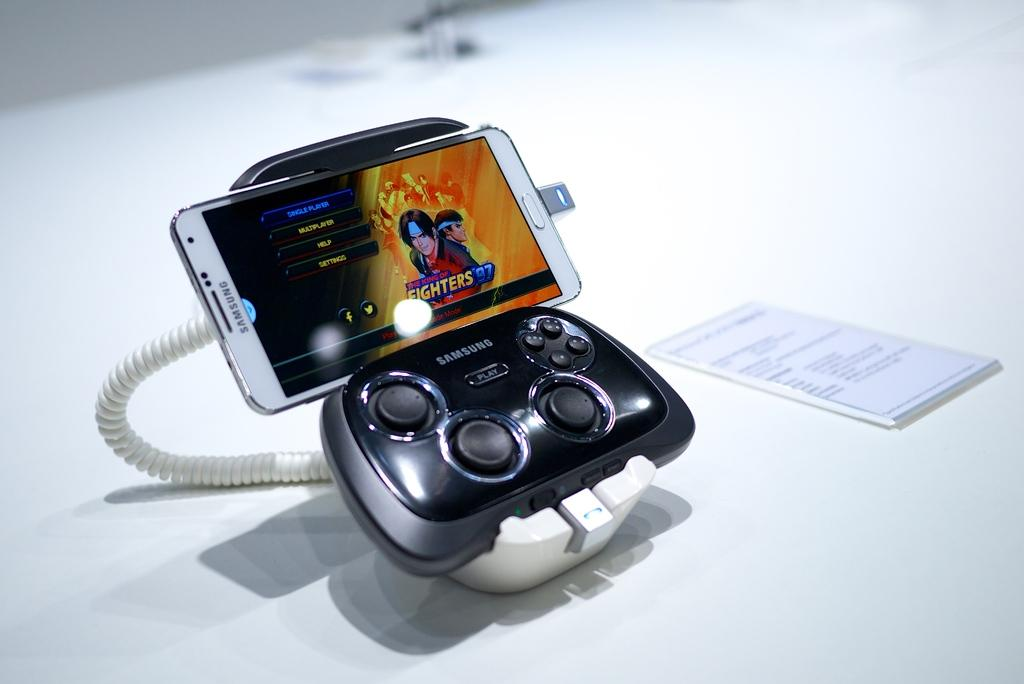Provide a one-sentence caption for the provided image. A samsung gaming system shows The King of Fighters '97 on the phone screen. 